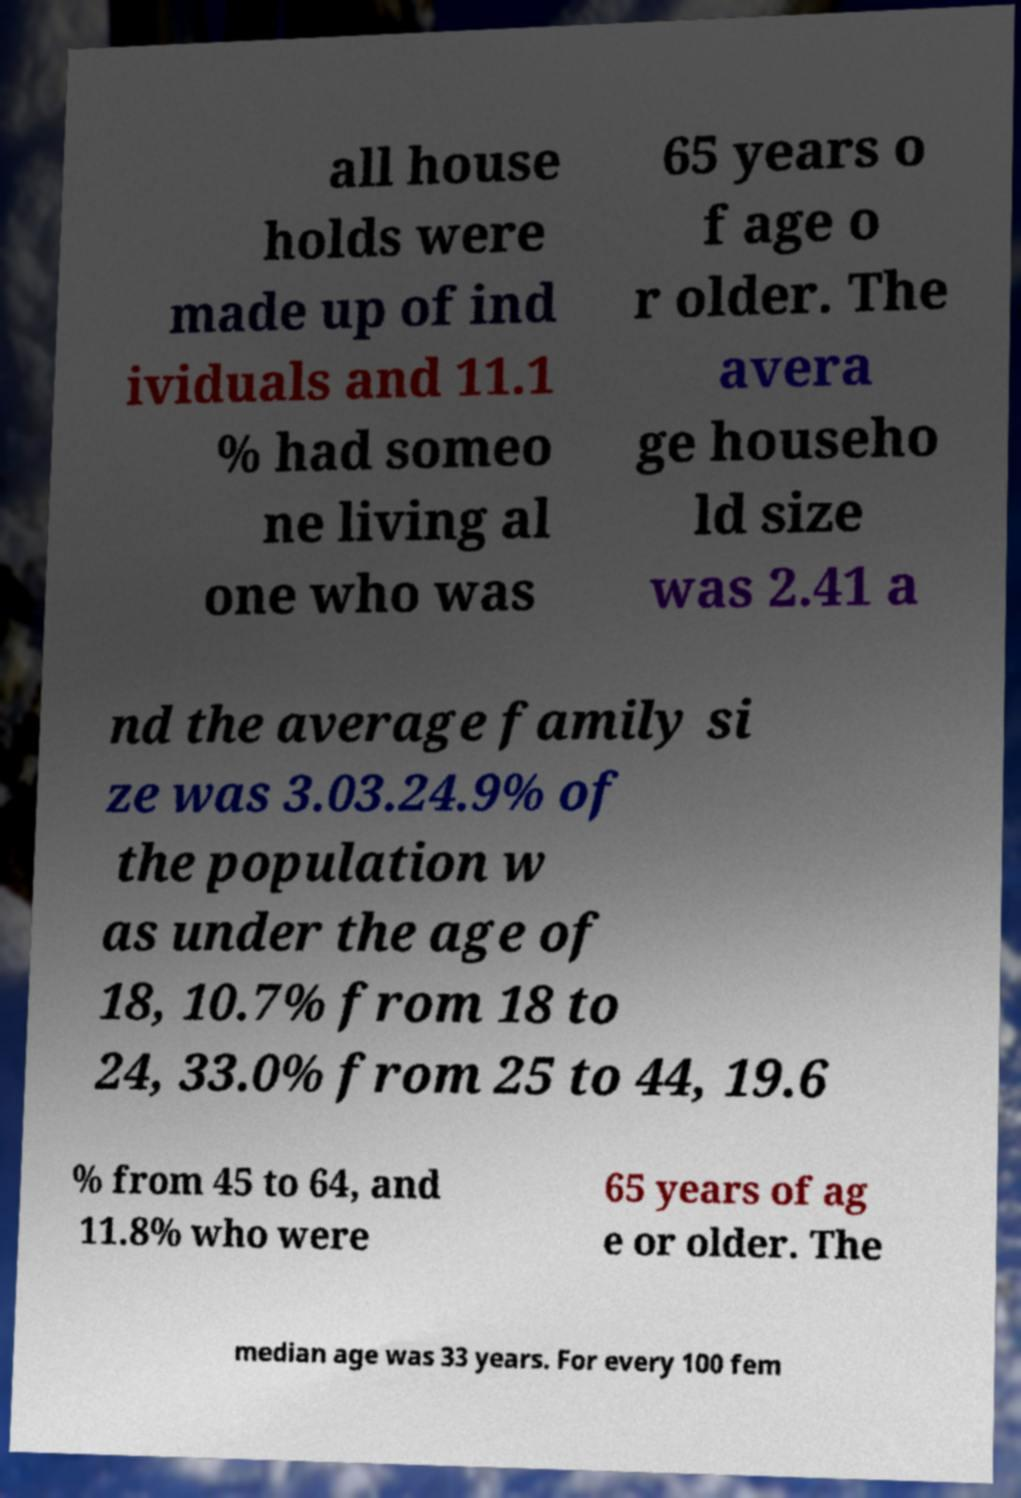Please identify and transcribe the text found in this image. all house holds were made up of ind ividuals and 11.1 % had someo ne living al one who was 65 years o f age o r older. The avera ge househo ld size was 2.41 a nd the average family si ze was 3.03.24.9% of the population w as under the age of 18, 10.7% from 18 to 24, 33.0% from 25 to 44, 19.6 % from 45 to 64, and 11.8% who were 65 years of ag e or older. The median age was 33 years. For every 100 fem 